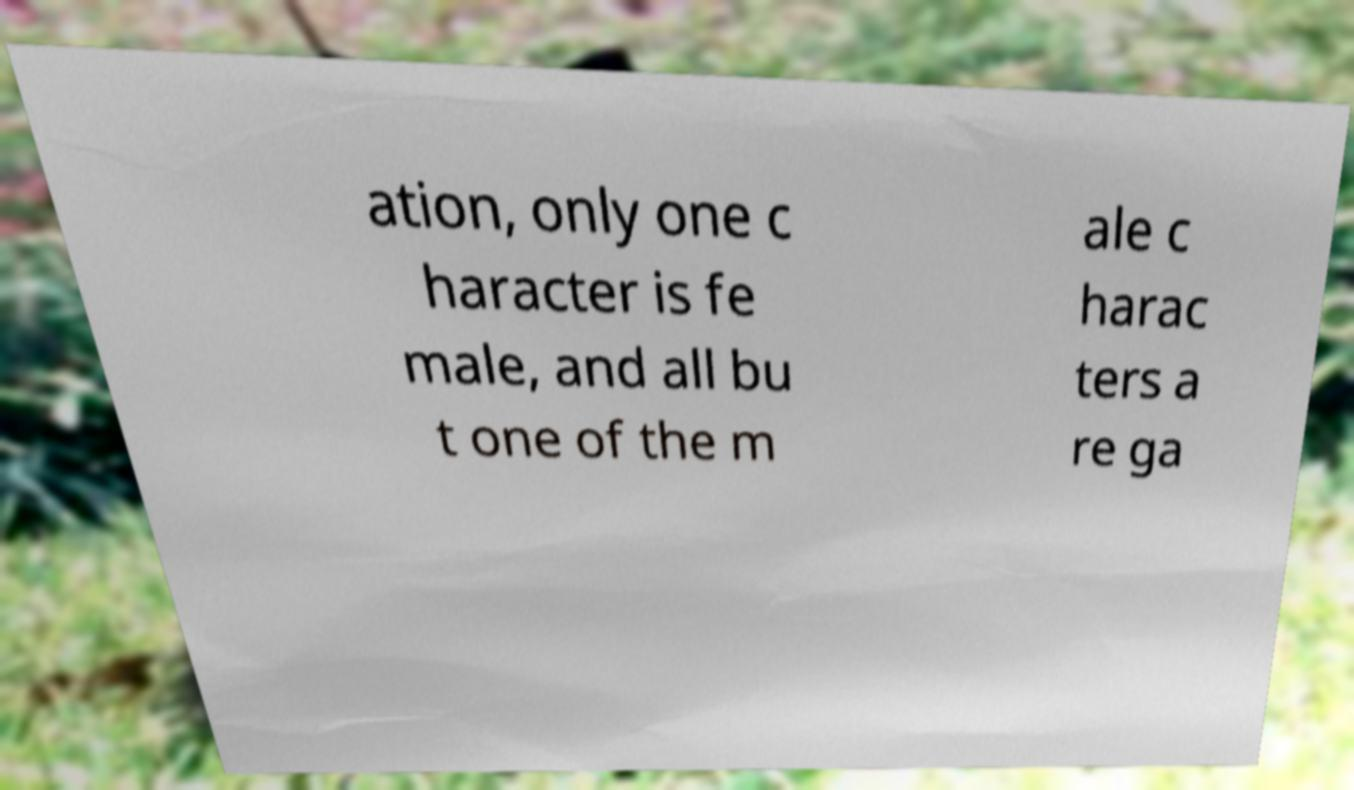For documentation purposes, I need the text within this image transcribed. Could you provide that? ation, only one c haracter is fe male, and all bu t one of the m ale c harac ters a re ga 